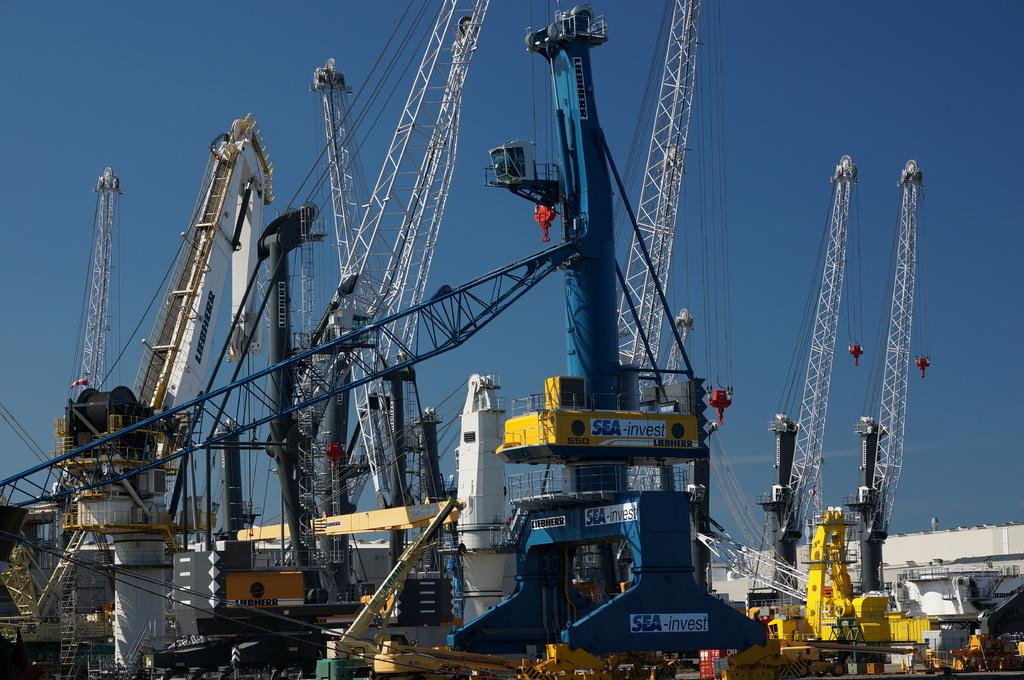What type of machines are located at the bottom of the image? There are crane machines in the image. Where is the building in relation to the image? The building is on the right side of the image. What is visible at the top of the image? The sky is visible at the top of the image. How many beginner badges are visible on the crane machines in the image? There is no mention of badges or skill levels in the image, so it is not possible to determine the number of beginner badges. 